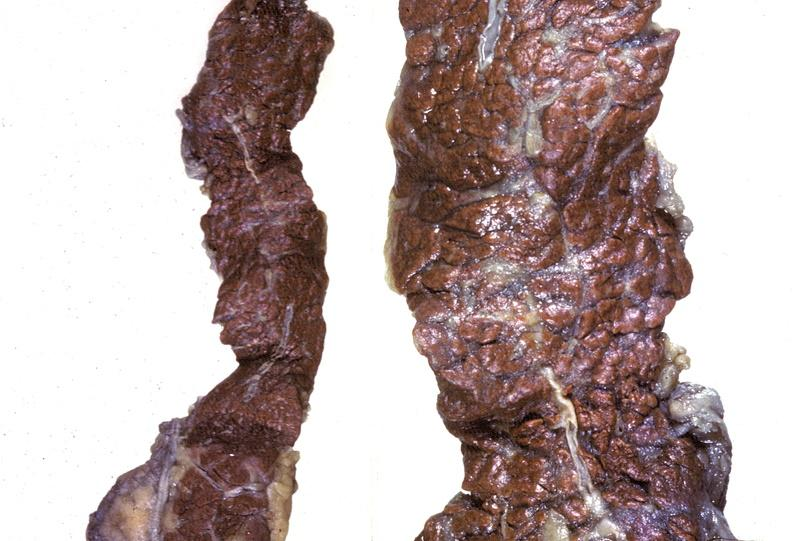what does this image show?
Answer the question using a single word or phrase. Pancreas 